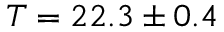Convert formula to latex. <formula><loc_0><loc_0><loc_500><loc_500>T = 2 2 . 3 \pm 0 . 4</formula> 